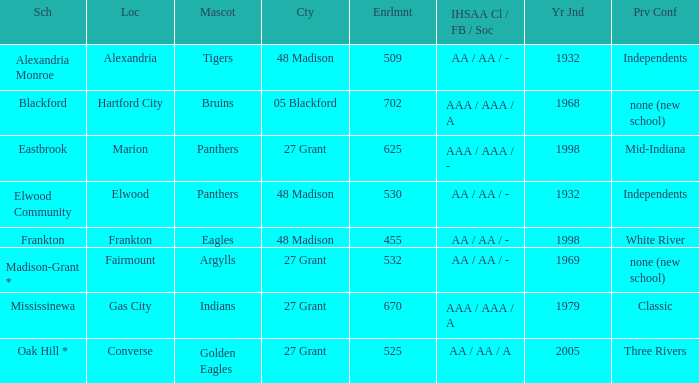What is the school with the location of alexandria? Alexandria Monroe. 